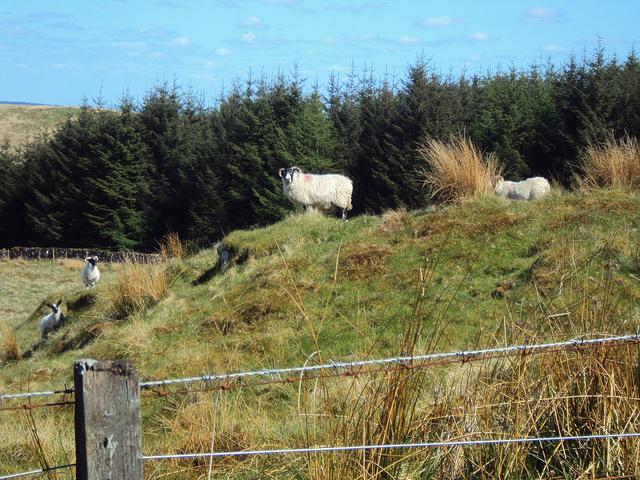Are there any people in this photo?
Keep it brief. No. Sunny or overcast?
Quick response, please. Sunny. What kind of fence  is pictured?
Keep it brief. Barbed wire. 